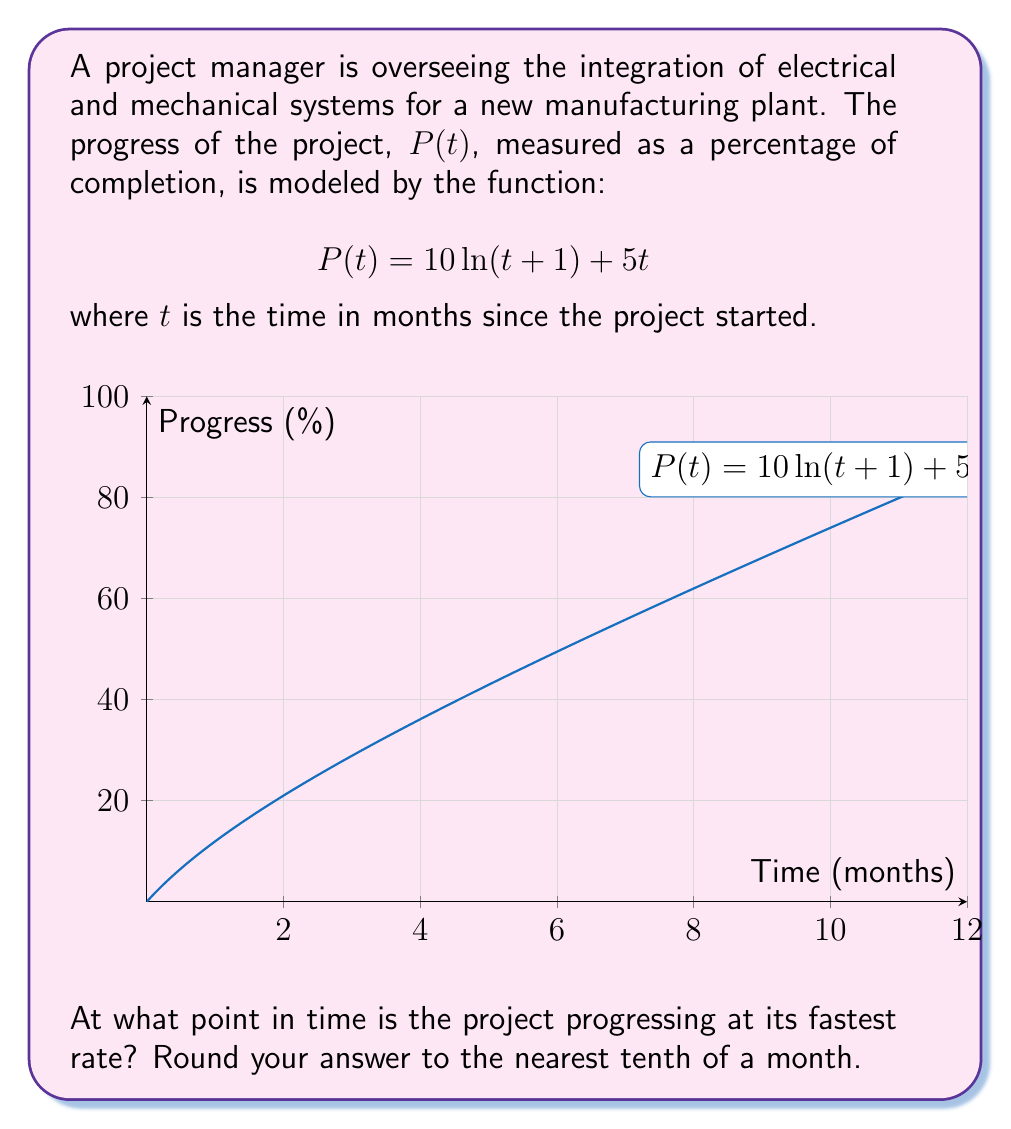Give your solution to this math problem. To find when the project is progressing at its fastest rate, we need to determine the maximum value of the rate of change, which is given by the derivative of $P(t)$.

Step 1: Calculate the derivative of $P(t)$.
$$P'(t) = \frac{d}{dt}[10\ln(t+1) + 5t] = \frac{10}{t+1} + 5$$

Step 2: To find the maximum rate of change, we need to find where the second derivative equals zero.
$$P''(t) = \frac{d}{dt}[\frac{10}{t+1} + 5] = -\frac{10}{(t+1)^2}$$

Step 3: Set $P''(t) = 0$ and solve for $t$.
$$-\frac{10}{(t+1)^2} = 0$$
This equation has no solution, which means there is no maximum rate of change.

Step 4: Analyze the behavior of $P'(t)$.
As $t$ increases, $\frac{10}{t+1}$ approaches 0, so $P'(t)$ approaches 5 from above.
As $t$ approaches $-1$, $P'(t)$ approaches positive infinity.

Step 5: Conclude that the fastest rate occurs at the start of the project, when $t = 0$.

$$P'(0) = \frac{10}{0+1} + 5 = 15$$

Therefore, the project is progressing at its fastest rate at the beginning, when $t = 0$ months.
Answer: 0 months 